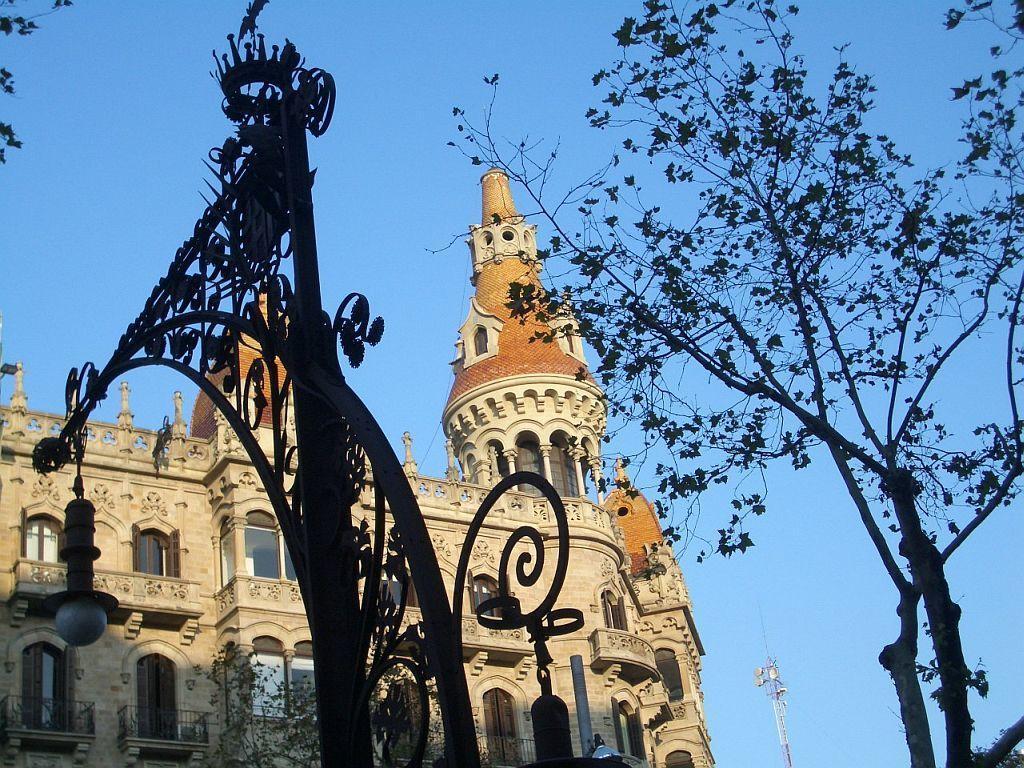In one or two sentences, can you explain what this image depicts? In the picture we can see a pole with some designs and lamp to it and besides it we can see a tree and in the background we can see a building with some architect to it and beside it we can see a tower and sky. 